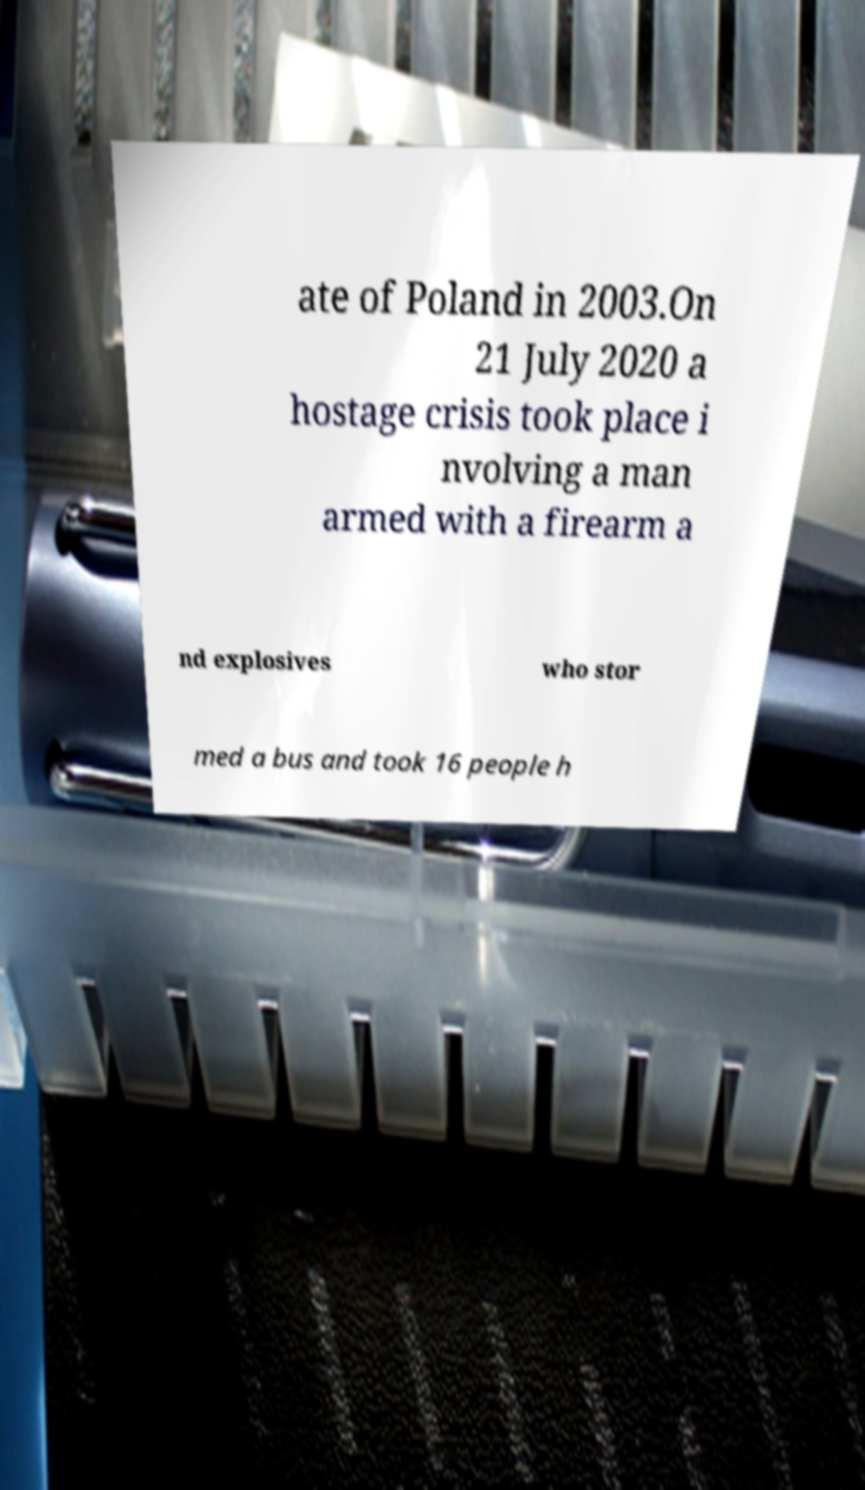Please read and relay the text visible in this image. What does it say? ate of Poland in 2003.On 21 July 2020 a hostage crisis took place i nvolving a man armed with a firearm a nd explosives who stor med a bus and took 16 people h 